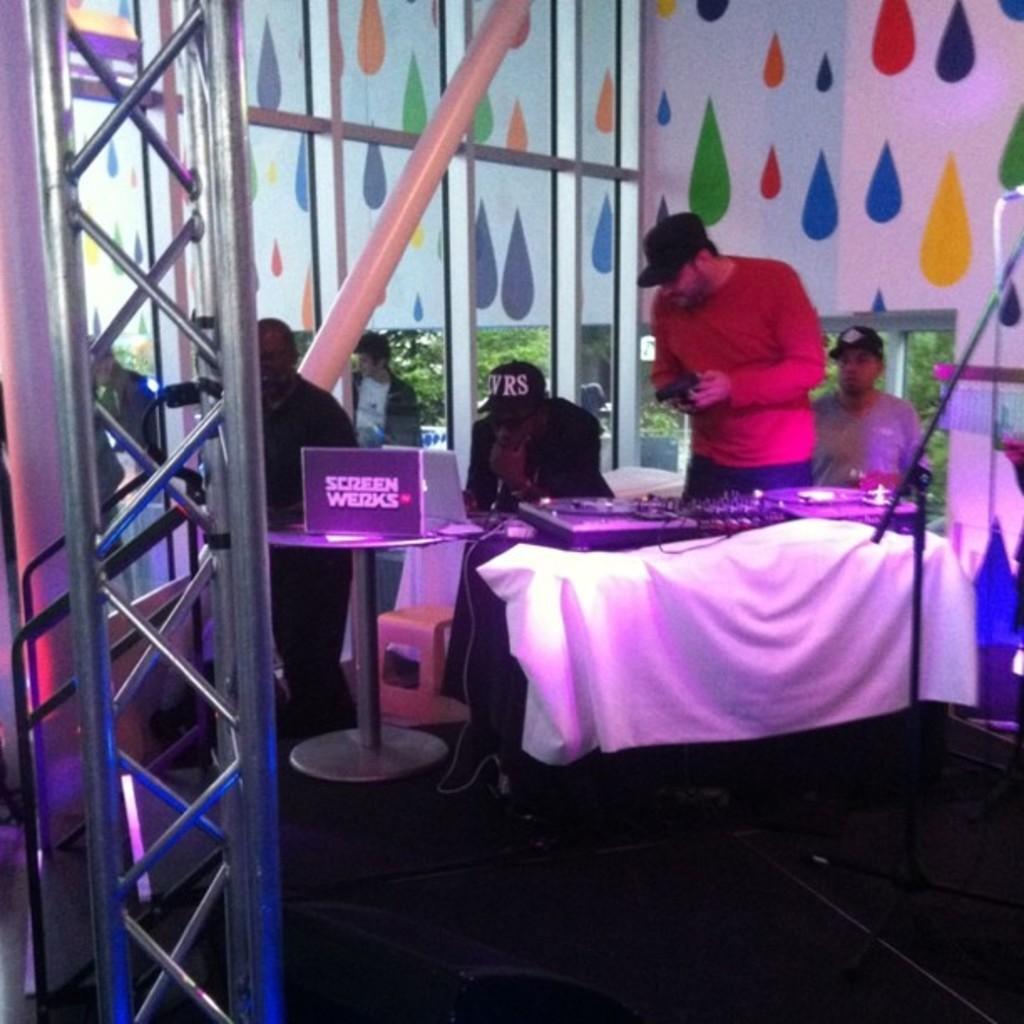Please provide a concise description of this image. In this image I can see the group of people with different color dresses. I can see few people wearing the caps. In-front of few people I can see the musical instruments on the table. I can also see the board on another table. In the background I can see the glass and the colorful wall. I can also see the trees and the sky through the glass. 